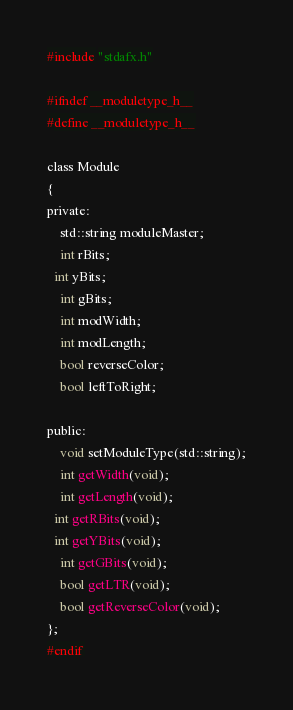Convert code to text. <code><loc_0><loc_0><loc_500><loc_500><_C_>#include "stdafx.h"

#ifndef __moduletype_h__
#define __moduletype_h__

class Module
{
private:
	std::string moduleMaster;
	int rBits;
  int yBits;
	int gBits;
	int modWidth;
	int modLength;
	bool reverseColor;
	bool leftToRight;

public:
	void setModuleType(std::string);
	int getWidth(void);
	int getLength(void);
  int getRBits(void);
  int getYBits(void);
	int getGBits(void);
	bool getLTR(void);
	bool getReverseColor(void);
};
#endif</code> 